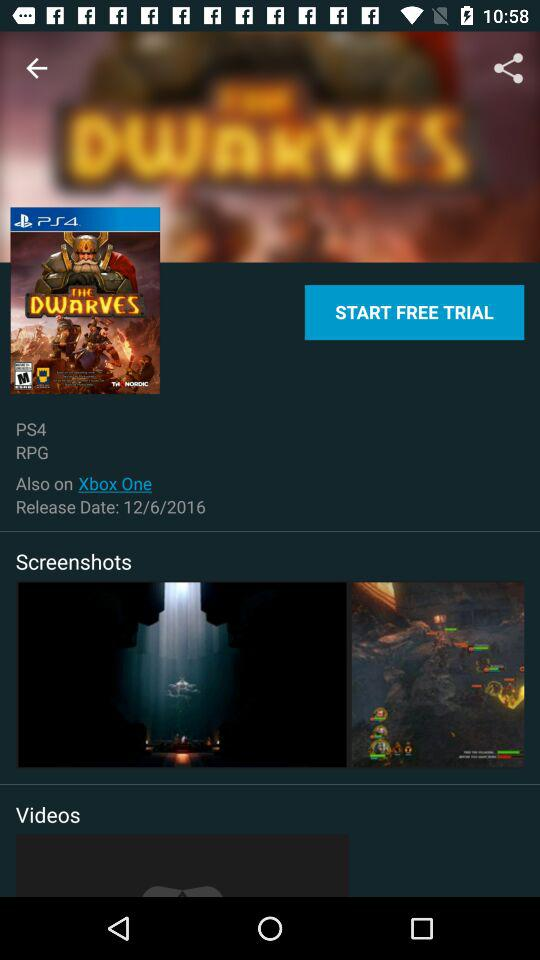What is the charge for the trial? The trial is free. 